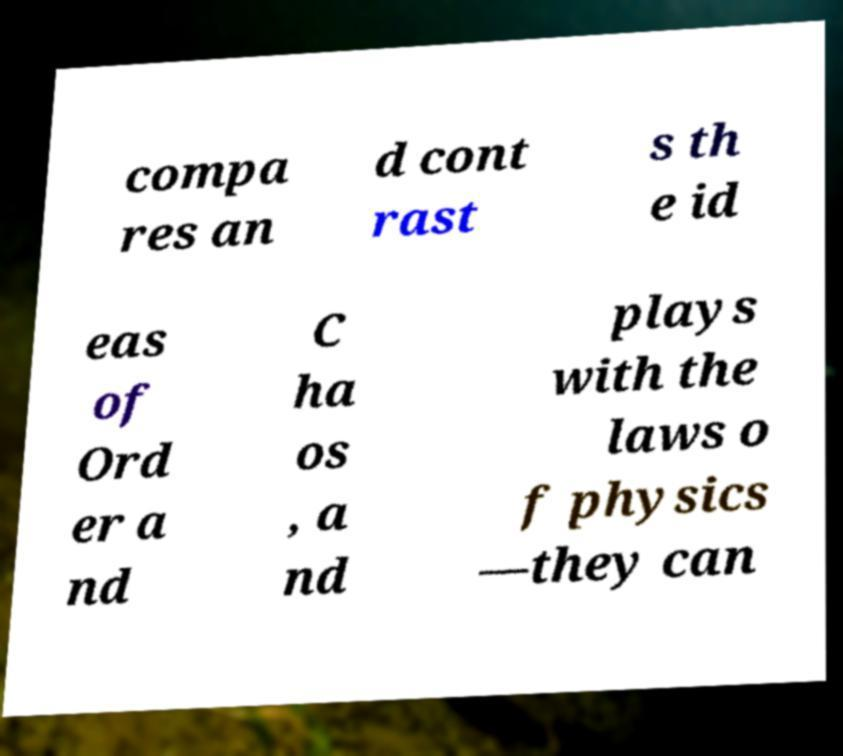Can you accurately transcribe the text from the provided image for me? compa res an d cont rast s th e id eas of Ord er a nd C ha os , a nd plays with the laws o f physics —they can 